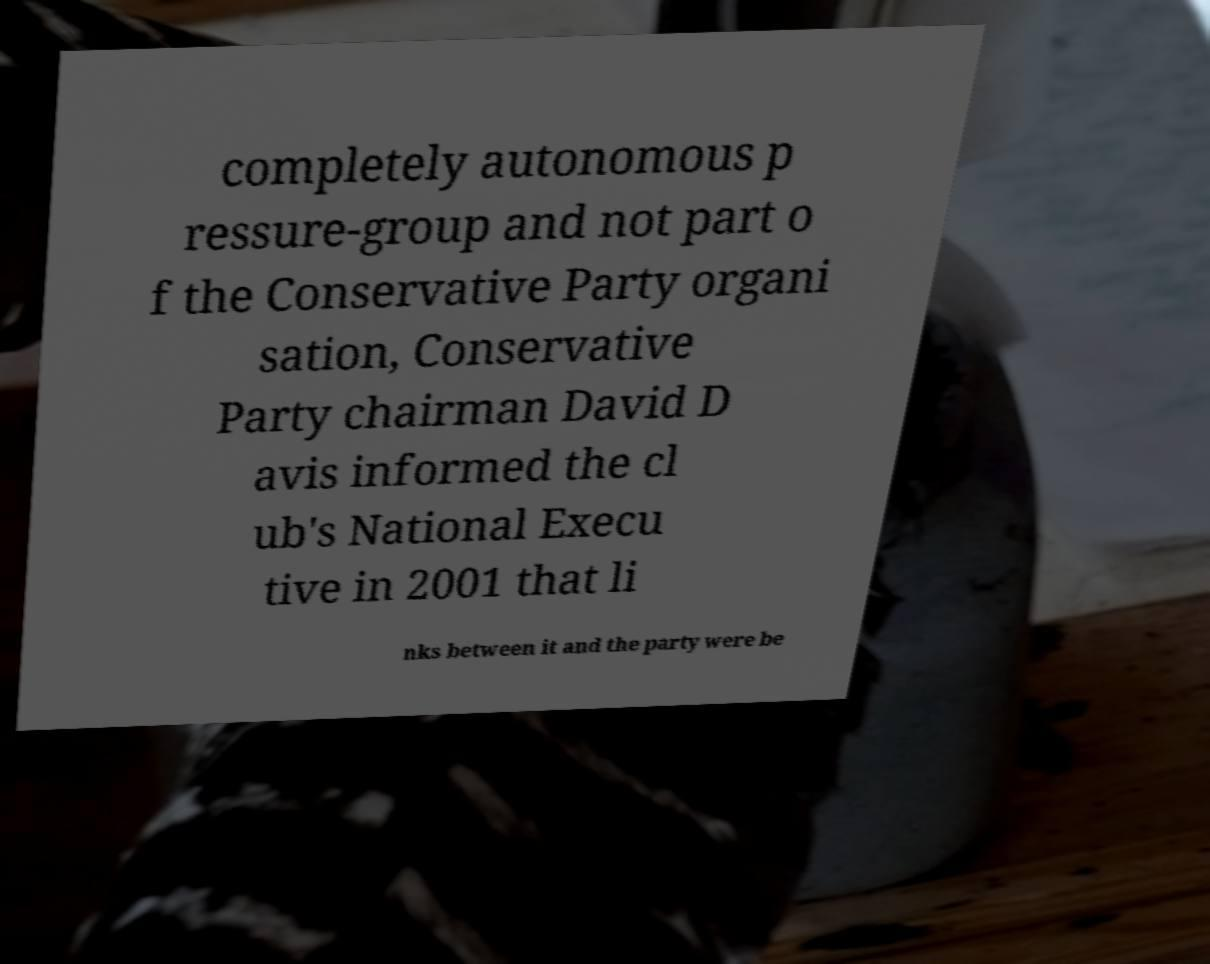Please identify and transcribe the text found in this image. completely autonomous p ressure-group and not part o f the Conservative Party organi sation, Conservative Party chairman David D avis informed the cl ub's National Execu tive in 2001 that li nks between it and the party were be 